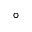Convert formula to latex. <formula><loc_0><loc_0><loc_500><loc_500>^ { \circ }</formula> 